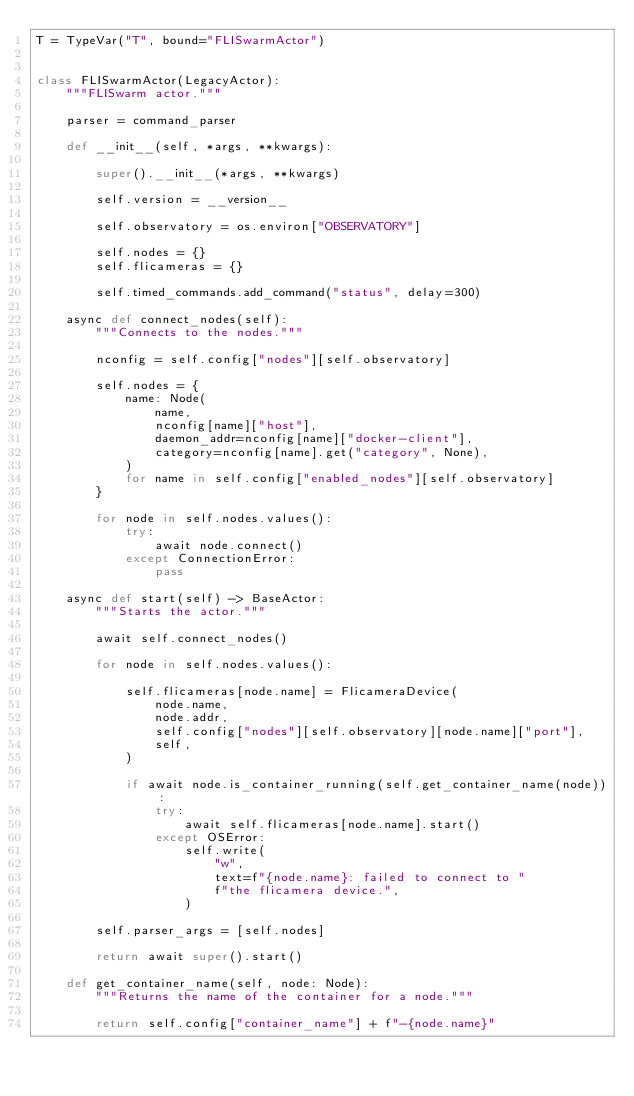<code> <loc_0><loc_0><loc_500><loc_500><_Python_>T = TypeVar("T", bound="FLISwarmActor")


class FLISwarmActor(LegacyActor):
    """FLISwarm actor."""

    parser = command_parser

    def __init__(self, *args, **kwargs):

        super().__init__(*args, **kwargs)

        self.version = __version__

        self.observatory = os.environ["OBSERVATORY"]

        self.nodes = {}
        self.flicameras = {}

        self.timed_commands.add_command("status", delay=300)

    async def connect_nodes(self):
        """Connects to the nodes."""

        nconfig = self.config["nodes"][self.observatory]

        self.nodes = {
            name: Node(
                name,
                nconfig[name]["host"],
                daemon_addr=nconfig[name]["docker-client"],
                category=nconfig[name].get("category", None),
            )
            for name in self.config["enabled_nodes"][self.observatory]
        }

        for node in self.nodes.values():
            try:
                await node.connect()
            except ConnectionError:
                pass

    async def start(self) -> BaseActor:
        """Starts the actor."""

        await self.connect_nodes()

        for node in self.nodes.values():

            self.flicameras[node.name] = FlicameraDevice(
                node.name,
                node.addr,
                self.config["nodes"][self.observatory][node.name]["port"],
                self,
            )

            if await node.is_container_running(self.get_container_name(node)):
                try:
                    await self.flicameras[node.name].start()
                except OSError:
                    self.write(
                        "w",
                        text=f"{node.name}: failed to connect to "
                        f"the flicamera device.",
                    )

        self.parser_args = [self.nodes]

        return await super().start()

    def get_container_name(self, node: Node):
        """Returns the name of the container for a node."""

        return self.config["container_name"] + f"-{node.name}"
</code> 